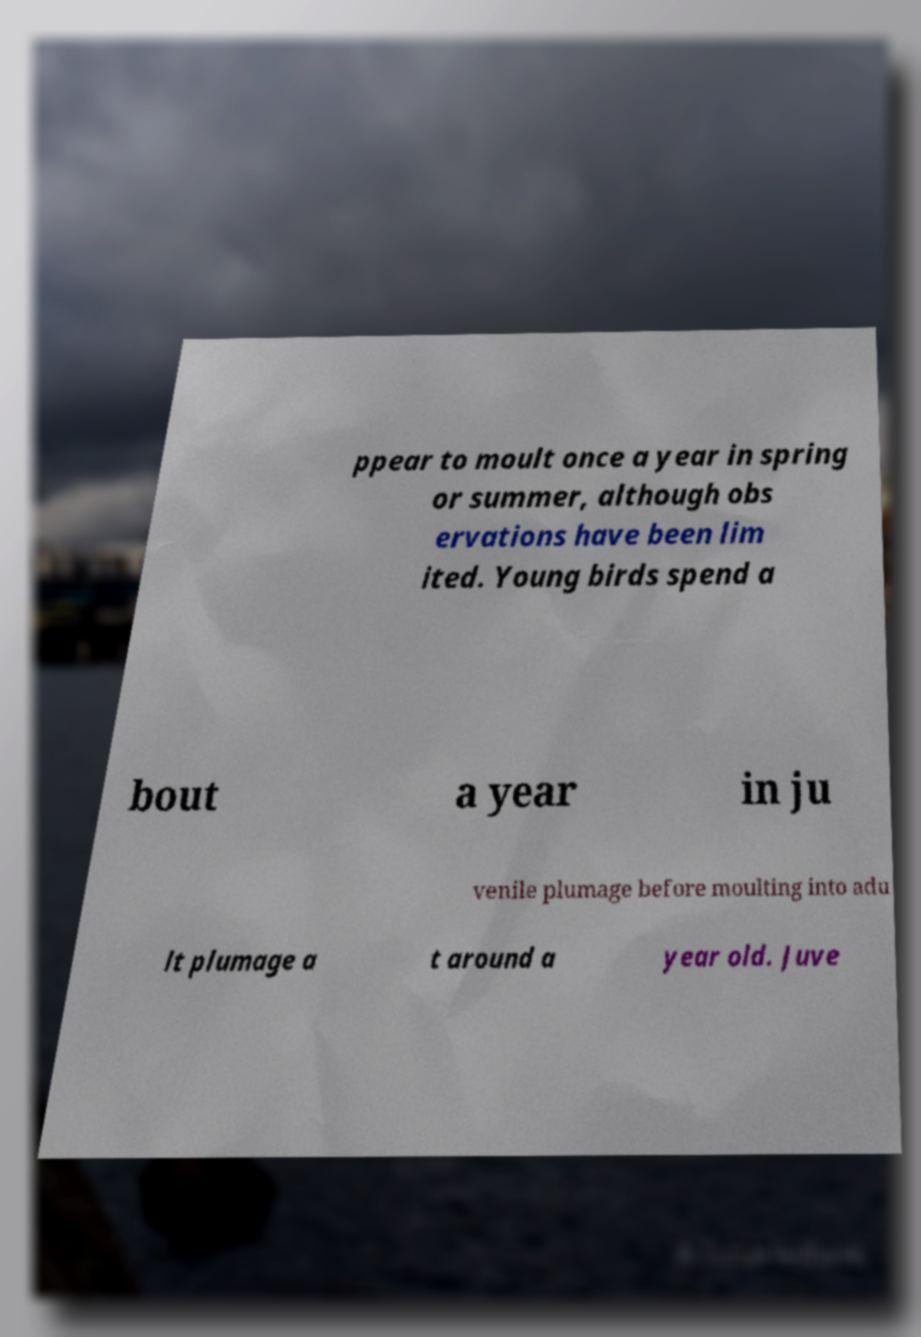Could you assist in decoding the text presented in this image and type it out clearly? ppear to moult once a year in spring or summer, although obs ervations have been lim ited. Young birds spend a bout a year in ju venile plumage before moulting into adu lt plumage a t around a year old. Juve 